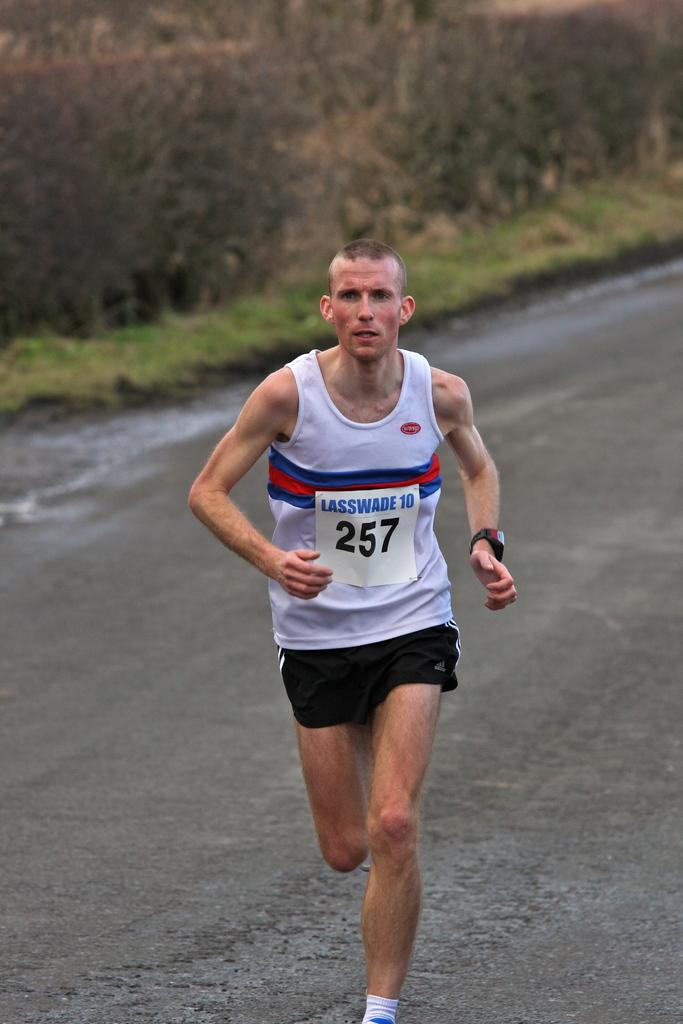<image>
Share a concise interpretation of the image provided. A runner has a placard that reads number 257 in black letters. 